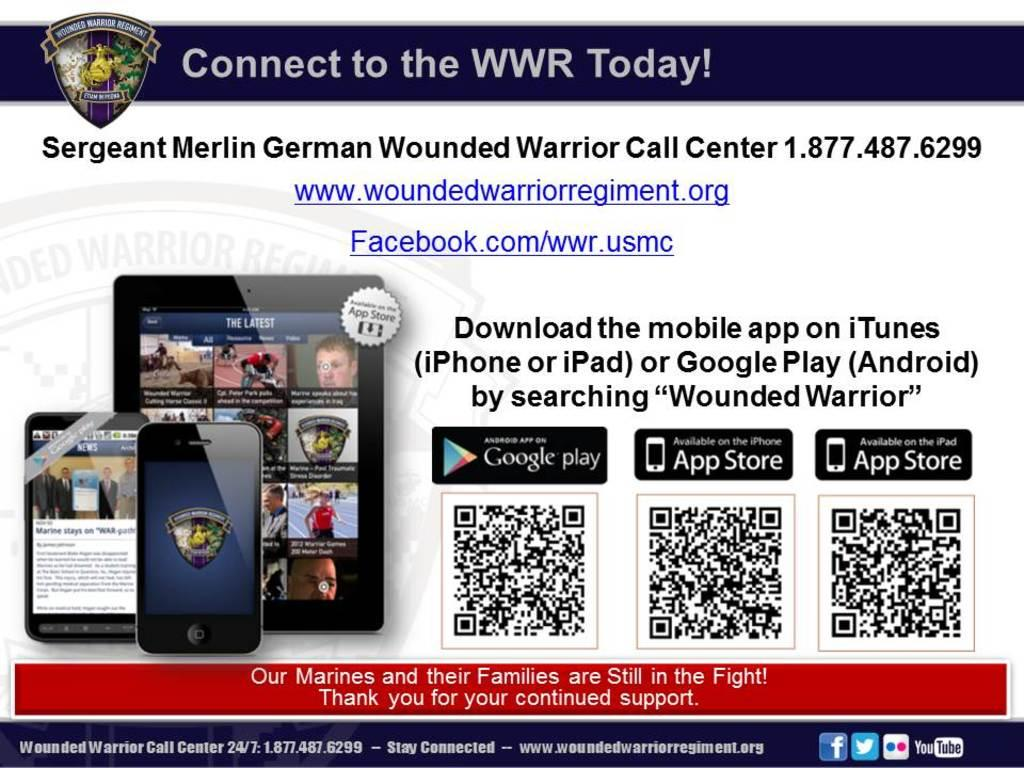Provide a one-sentence caption for the provided image. An advertisement is for the Wounded Warrior's and includes contact information. 